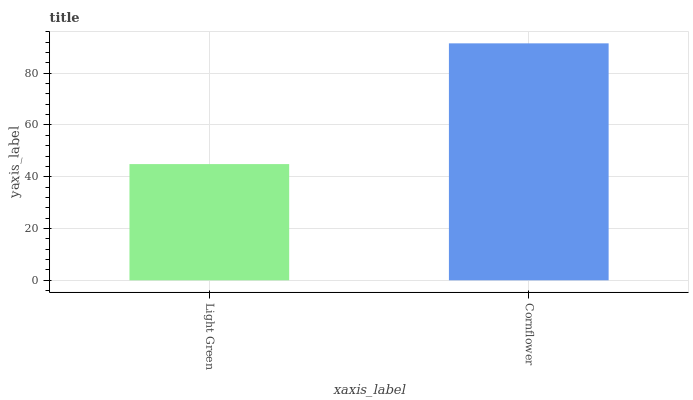Is Cornflower the minimum?
Answer yes or no. No. Is Cornflower greater than Light Green?
Answer yes or no. Yes. Is Light Green less than Cornflower?
Answer yes or no. Yes. Is Light Green greater than Cornflower?
Answer yes or no. No. Is Cornflower less than Light Green?
Answer yes or no. No. Is Cornflower the high median?
Answer yes or no. Yes. Is Light Green the low median?
Answer yes or no. Yes. Is Light Green the high median?
Answer yes or no. No. Is Cornflower the low median?
Answer yes or no. No. 